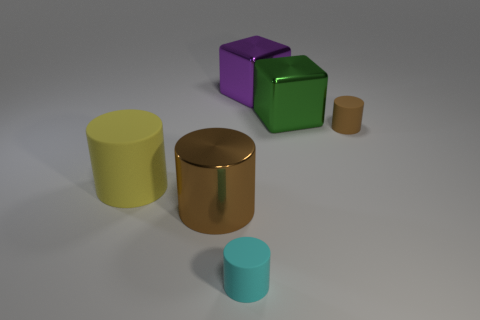There is a large purple metal object; are there any big metallic objects on the right side of it? Yes, to the right of the large purple object, there appears to be a smaller golden cylindrical object made of metal. 